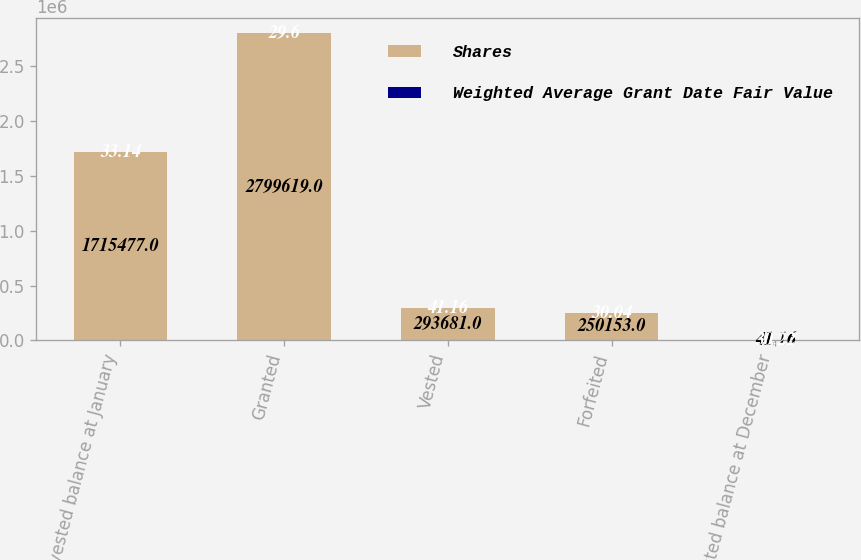Convert chart. <chart><loc_0><loc_0><loc_500><loc_500><stacked_bar_chart><ecel><fcel>Non-vested balance at January<fcel>Granted<fcel>Vested<fcel>Forfeited<fcel>Non-vested balance at December<nl><fcel>Shares<fcel>1.71548e+06<fcel>2.79962e+06<fcel>293681<fcel>250153<fcel>41.16<nl><fcel>Weighted Average Grant Date Fair Value<fcel>33.14<fcel>29.6<fcel>41.16<fcel>30.04<fcel>30.22<nl></chart> 